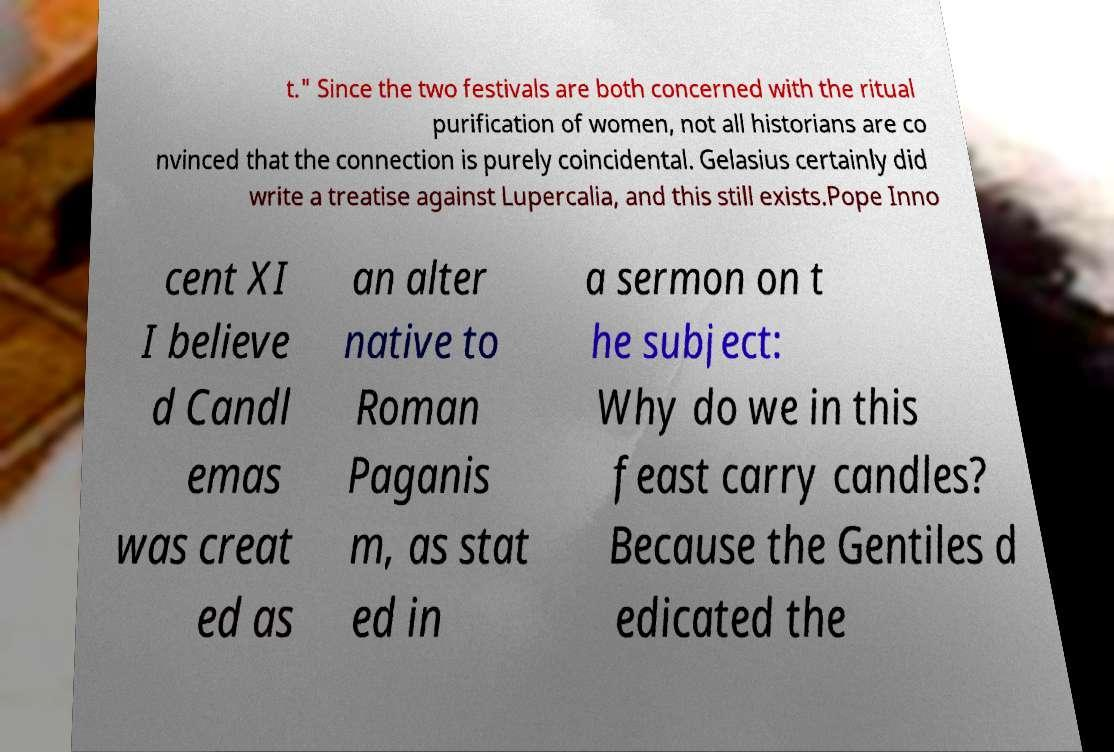Can you accurately transcribe the text from the provided image for me? t." Since the two festivals are both concerned with the ritual purification of women, not all historians are co nvinced that the connection is purely coincidental. Gelasius certainly did write a treatise against Lupercalia, and this still exists.Pope Inno cent XI I believe d Candl emas was creat ed as an alter native to Roman Paganis m, as stat ed in a sermon on t he subject: Why do we in this feast carry candles? Because the Gentiles d edicated the 